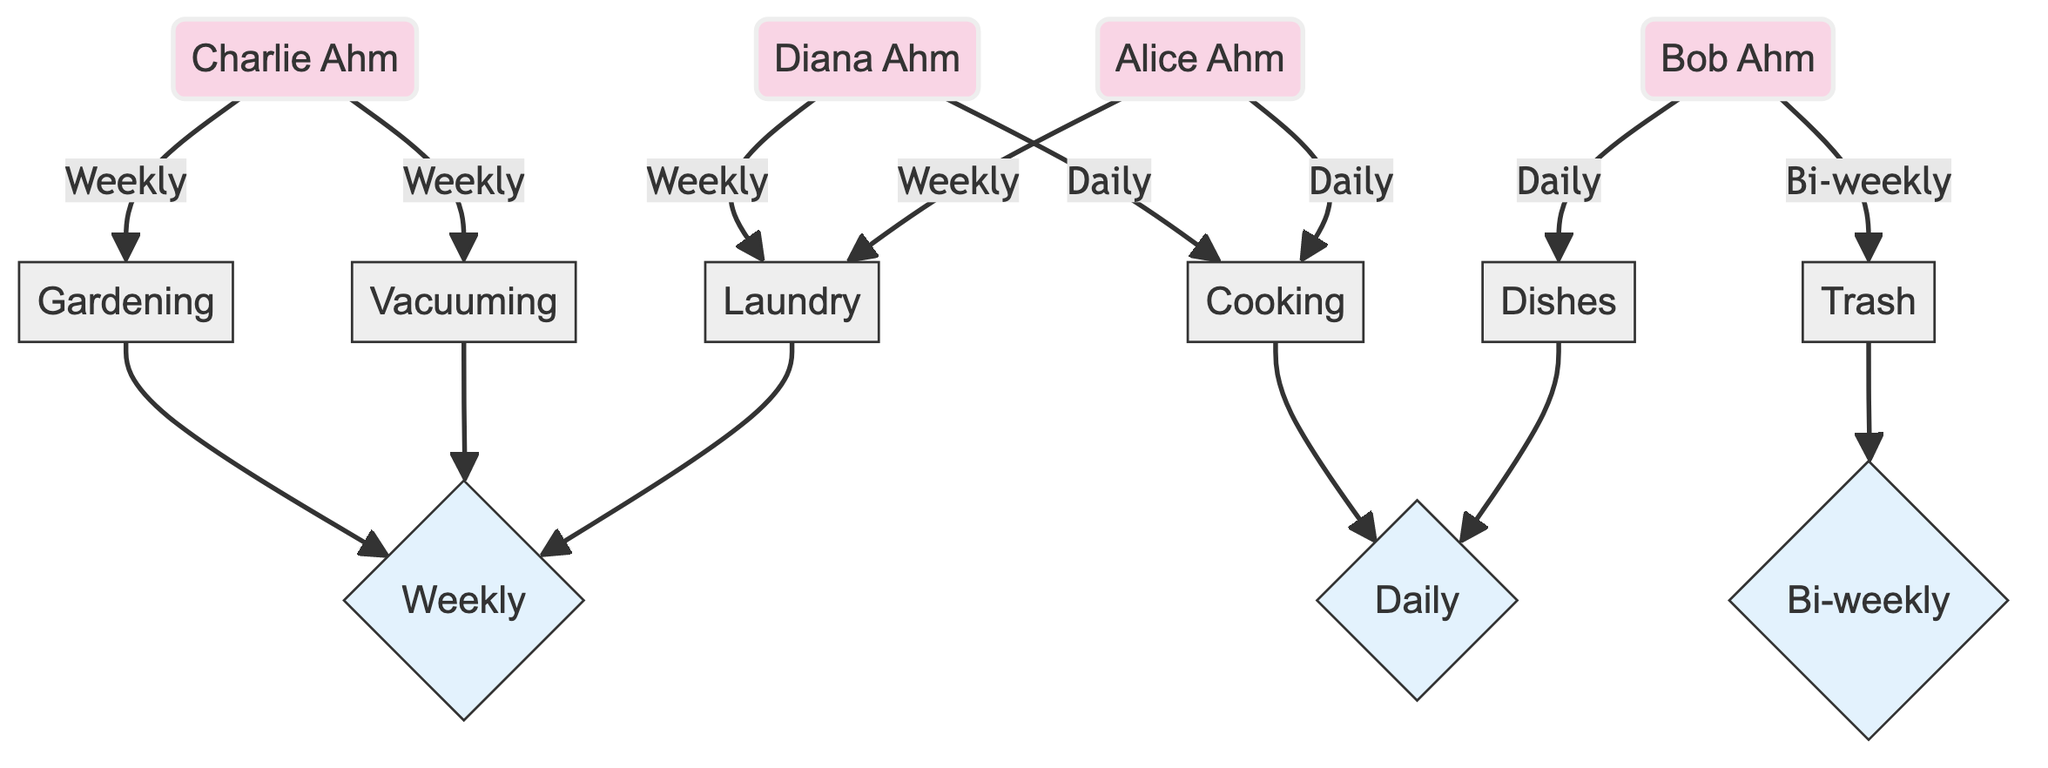What household chore is Alice responsible for? According to the diagram, Alice is connected to the Laundry and Cooking nodes. The edges show the tasks she is assigned, indicating the specific chores under her responsibility.
Answer: Laundry, Cooking How often does Bob perform Dishes? The diagram shows an edge from Bob to the Dishes node, annotated with the frequency 'Daily'. This directly indicates how often Bob is responsible for this chore.
Answer: Daily How many family members share the responsibility of Cooking? By examining the diagram, we see that both Alice and Diana are connected to the Cooking node, meaning they both take responsibility for this task.
Answer: 2 Which household chore does Charlie do weekly? The diagram indicates that Charlie is connected to both the Vacuuming and Gardening nodes, with edges specifying that he performs these tasks weekly. To answer the question, we refer to these connections.
Answer: Vacuuming, Gardening What is the frequency of the Trash chore? The edge from Bob to the Trash node indicates a frequency of 'Bi-weekly'. This shows the frequency at which the chore is performed according to the diagram.
Answer: Bi-weekly Which family member is responsible for Laundry along with Alice? In the diagram, both Alice and Diana are connected to the Laundry node, indicating they both share this responsibility at the same frequency.
Answer: Diana What type of graph is used to represent the household chores distribution? The diagram is a Directed Graph, which is explicitly charting responsibilities and frequencies of tasks among family members in one direction, from members to chores.
Answer: Directed Graph How often is Vacuuming performed according to the diagram? The edge from the Vacuuming node connects it to the FrequencyWeekly node, indicating that the Vacuuming chore is scheduled for weekly performance.
Answer: Weekly Which member takes out the Trash? The edge connects Bob to the Trash node, designating him as the family member responsible for this particular chore based on the diagram.
Answer: Bob 